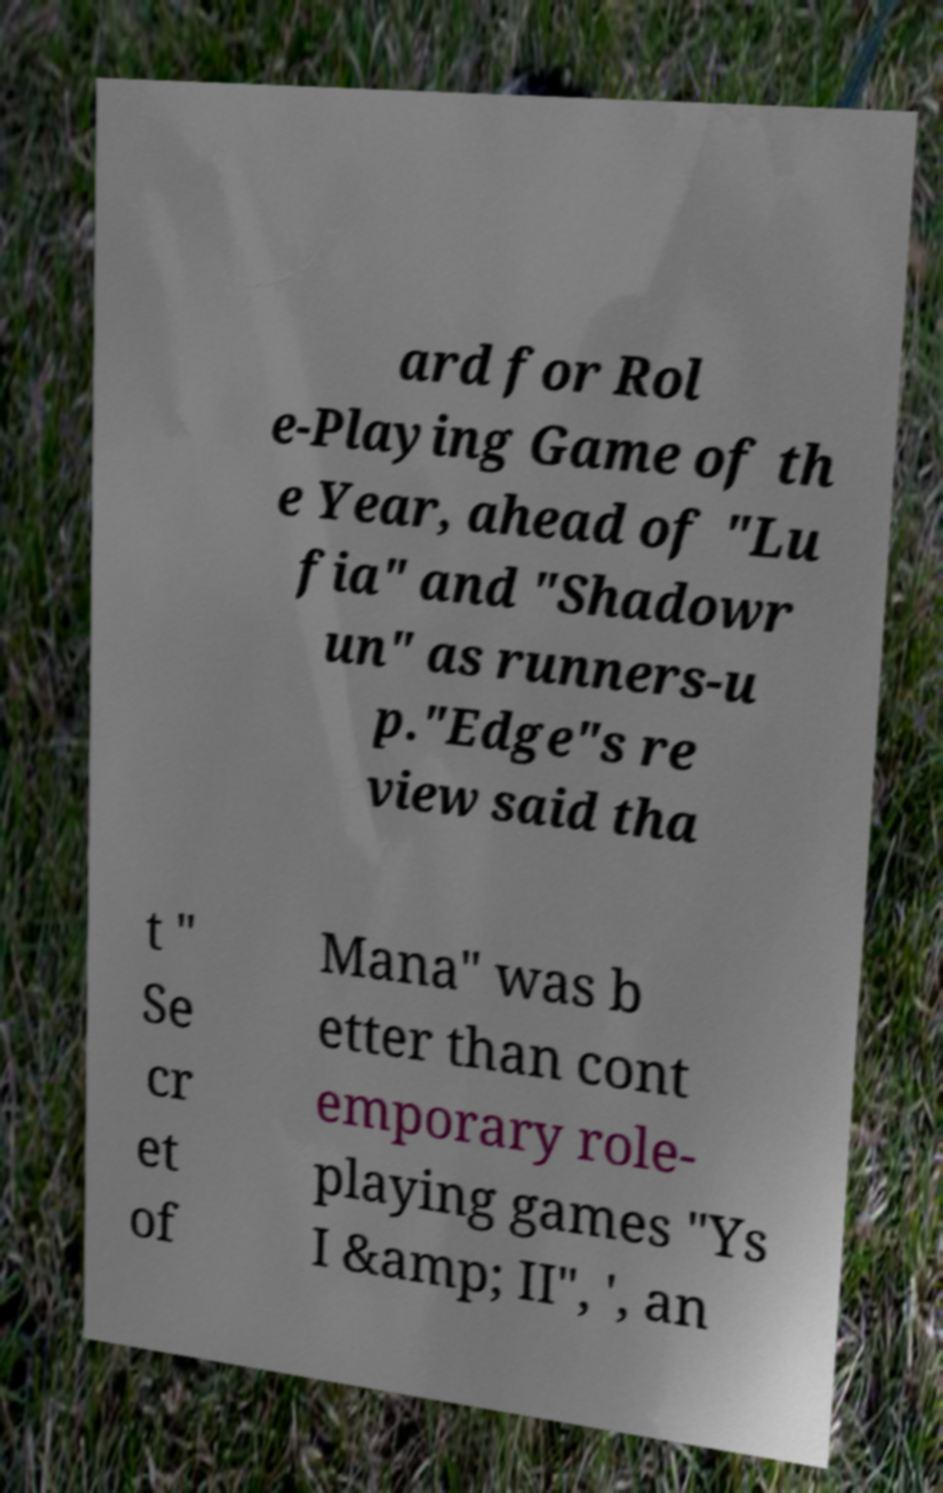Please identify and transcribe the text found in this image. ard for Rol e-Playing Game of th e Year, ahead of "Lu fia" and "Shadowr un" as runners-u p."Edge"s re view said tha t " Se cr et of Mana" was b etter than cont emporary role- playing games "Ys I &amp; II", ', an 